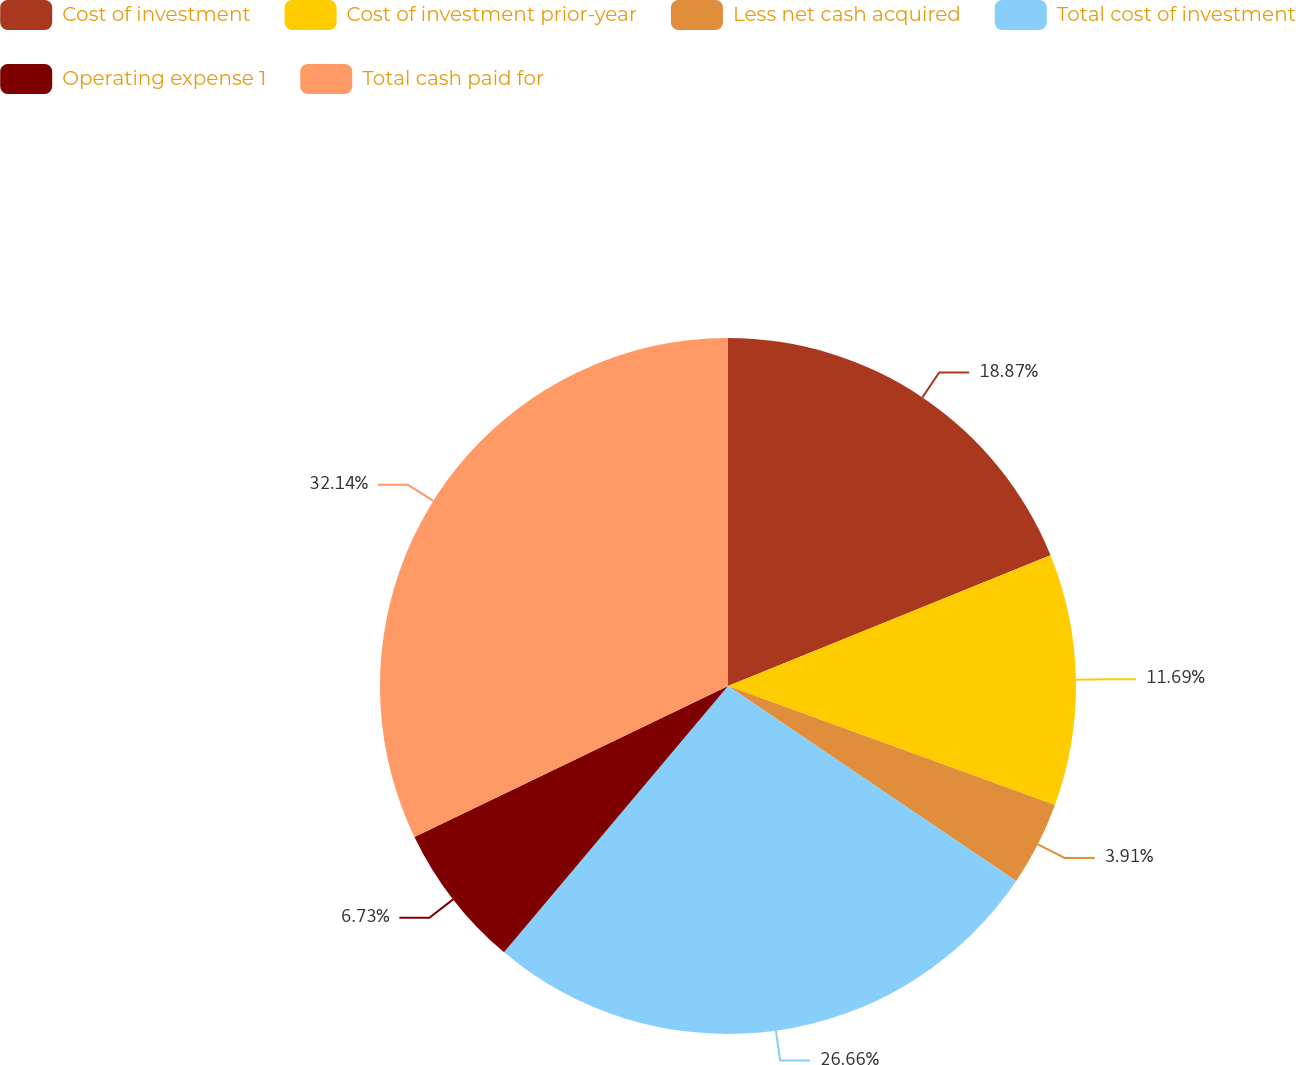Convert chart. <chart><loc_0><loc_0><loc_500><loc_500><pie_chart><fcel>Cost of investment<fcel>Cost of investment prior-year<fcel>Less net cash acquired<fcel>Total cost of investment<fcel>Operating expense 1<fcel>Total cash paid for<nl><fcel>18.87%<fcel>11.69%<fcel>3.91%<fcel>26.66%<fcel>6.73%<fcel>32.14%<nl></chart> 